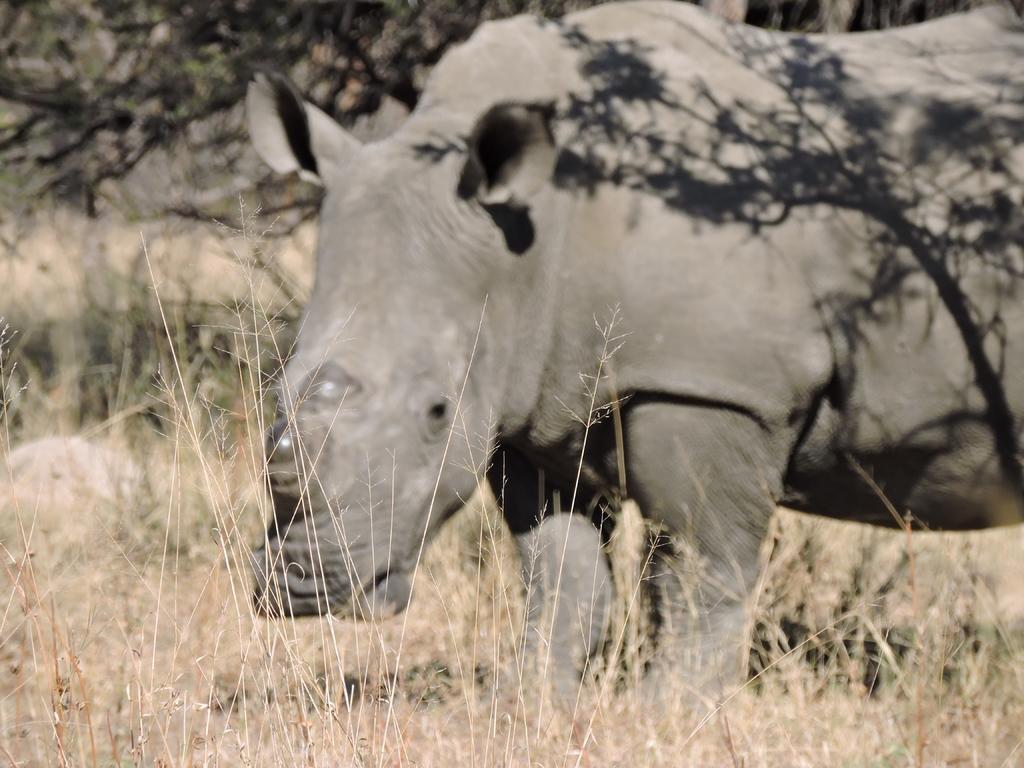Can you describe this image briefly? As we can see in the image there is dry grass, trees and hippopotamus.. 